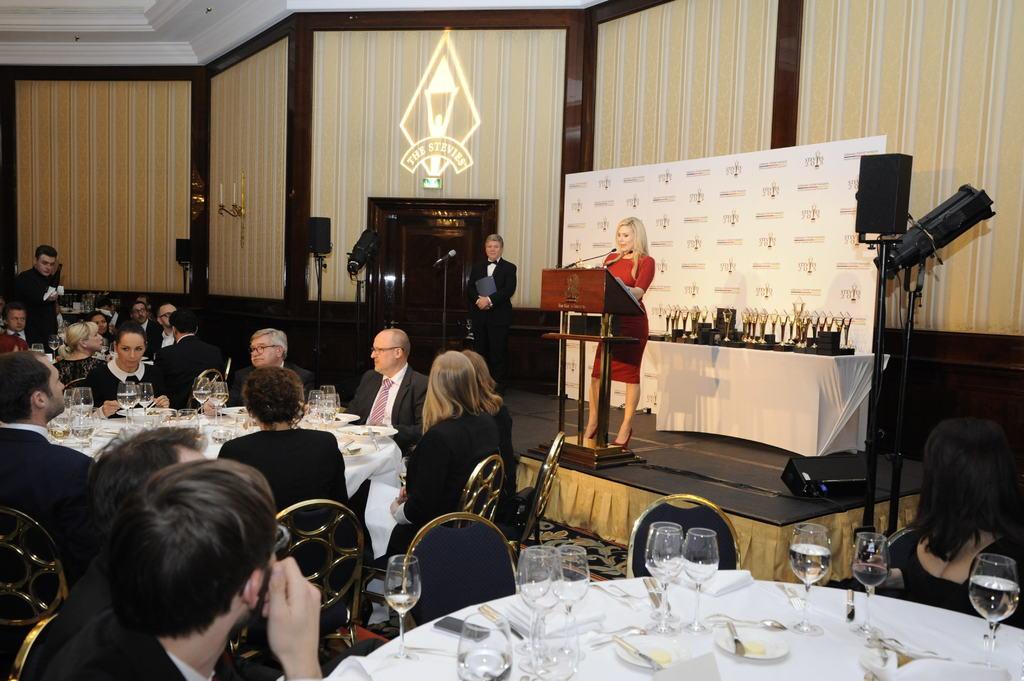How would you summarize this image in a sentence or two? In the foreground of this image, there are glasses, forks, spoons, tissues, platters on a table around which there are chairs and few people sitting on it. In the middle, there are people sitting around a table on which there are platters, glasses and few more objects. On the right, there is a woman standing in front of a podium on which there is a mic. Behind her, there are prizes on a desk, a banner wall, lights, wall, a man standing holding a black color object and the door. In the background, there are few people sitting and standing. At the top, there is ceiling. 